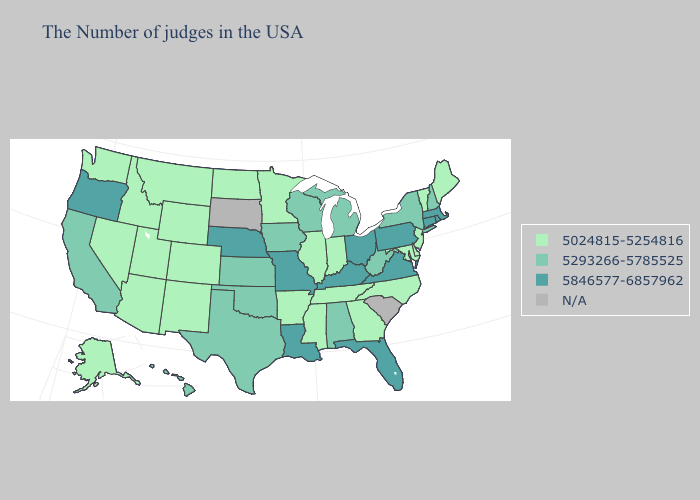Which states hav the highest value in the Northeast?
Short answer required. Massachusetts, Rhode Island, Connecticut, Pennsylvania. Name the states that have a value in the range N/A?
Write a very short answer. South Carolina, South Dakota. Name the states that have a value in the range N/A?
Quick response, please. South Carolina, South Dakota. Name the states that have a value in the range 5846577-6857962?
Write a very short answer. Massachusetts, Rhode Island, Connecticut, Pennsylvania, Virginia, Ohio, Florida, Kentucky, Louisiana, Missouri, Nebraska, Oregon. Among the states that border Minnesota , which have the highest value?
Quick response, please. Wisconsin, Iowa. Does Missouri have the highest value in the USA?
Keep it brief. Yes. What is the value of Michigan?
Keep it brief. 5293266-5785525. Name the states that have a value in the range 5846577-6857962?
Answer briefly. Massachusetts, Rhode Island, Connecticut, Pennsylvania, Virginia, Ohio, Florida, Kentucky, Louisiana, Missouri, Nebraska, Oregon. Among the states that border Pennsylvania , does West Virginia have the lowest value?
Concise answer only. No. What is the value of Hawaii?
Give a very brief answer. 5293266-5785525. Among the states that border California , which have the highest value?
Concise answer only. Oregon. What is the value of New York?
Be succinct. 5293266-5785525. Is the legend a continuous bar?
Keep it brief. No. Among the states that border North Carolina , which have the highest value?
Be succinct. Virginia. 